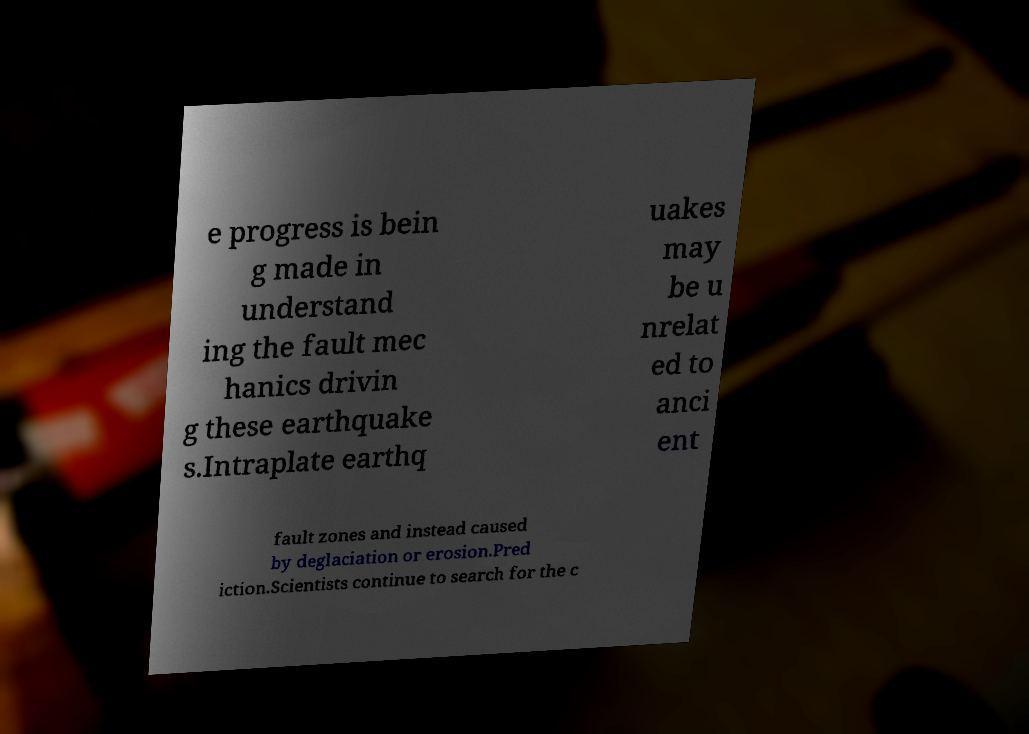For documentation purposes, I need the text within this image transcribed. Could you provide that? e progress is bein g made in understand ing the fault mec hanics drivin g these earthquake s.Intraplate earthq uakes may be u nrelat ed to anci ent fault zones and instead caused by deglaciation or erosion.Pred iction.Scientists continue to search for the c 